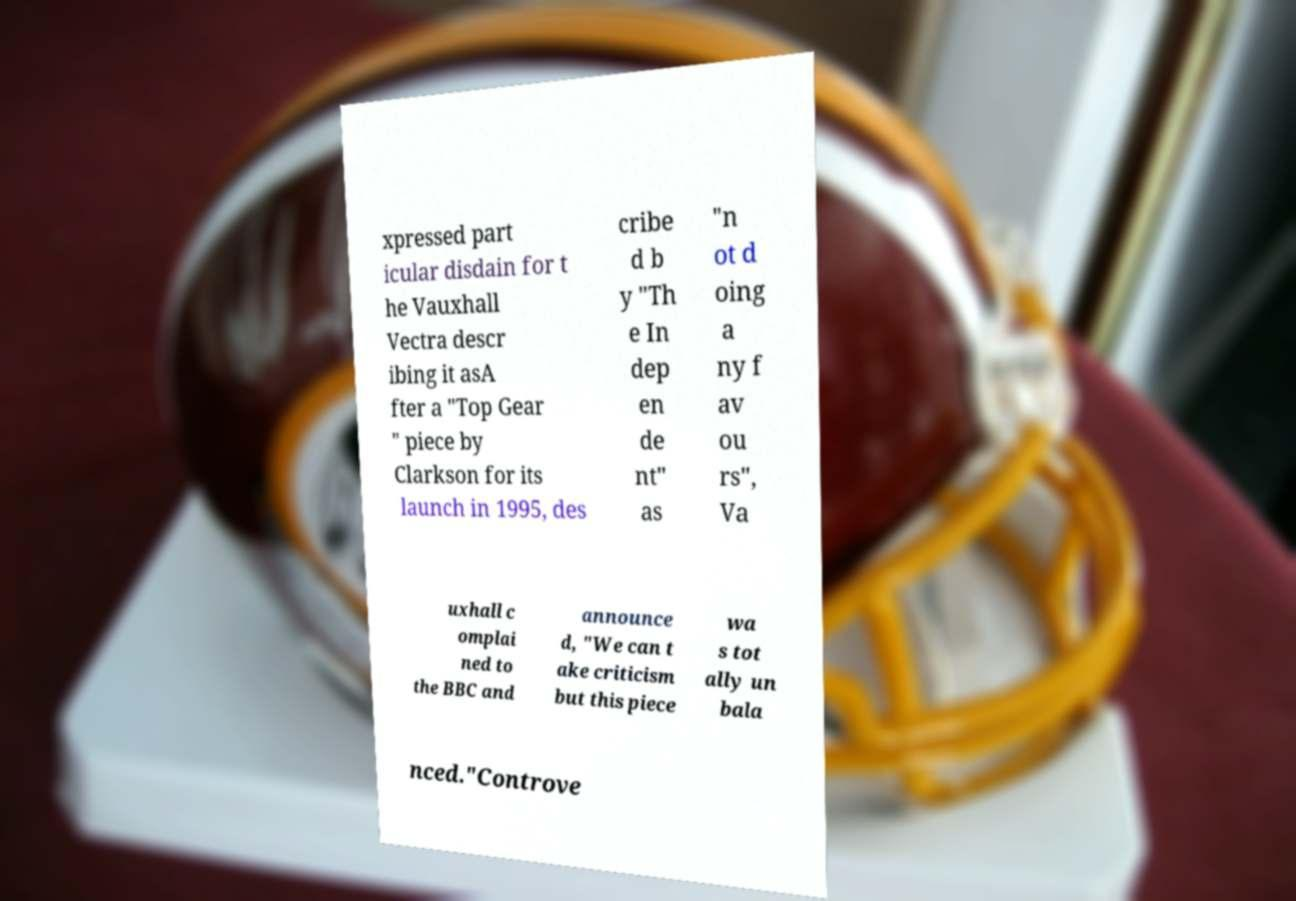Can you read and provide the text displayed in the image?This photo seems to have some interesting text. Can you extract and type it out for me? xpressed part icular disdain for t he Vauxhall Vectra descr ibing it asA fter a "Top Gear " piece by Clarkson for its launch in 1995, des cribe d b y "Th e In dep en de nt" as "n ot d oing a ny f av ou rs", Va uxhall c omplai ned to the BBC and announce d, "We can t ake criticism but this piece wa s tot ally un bala nced."Controve 